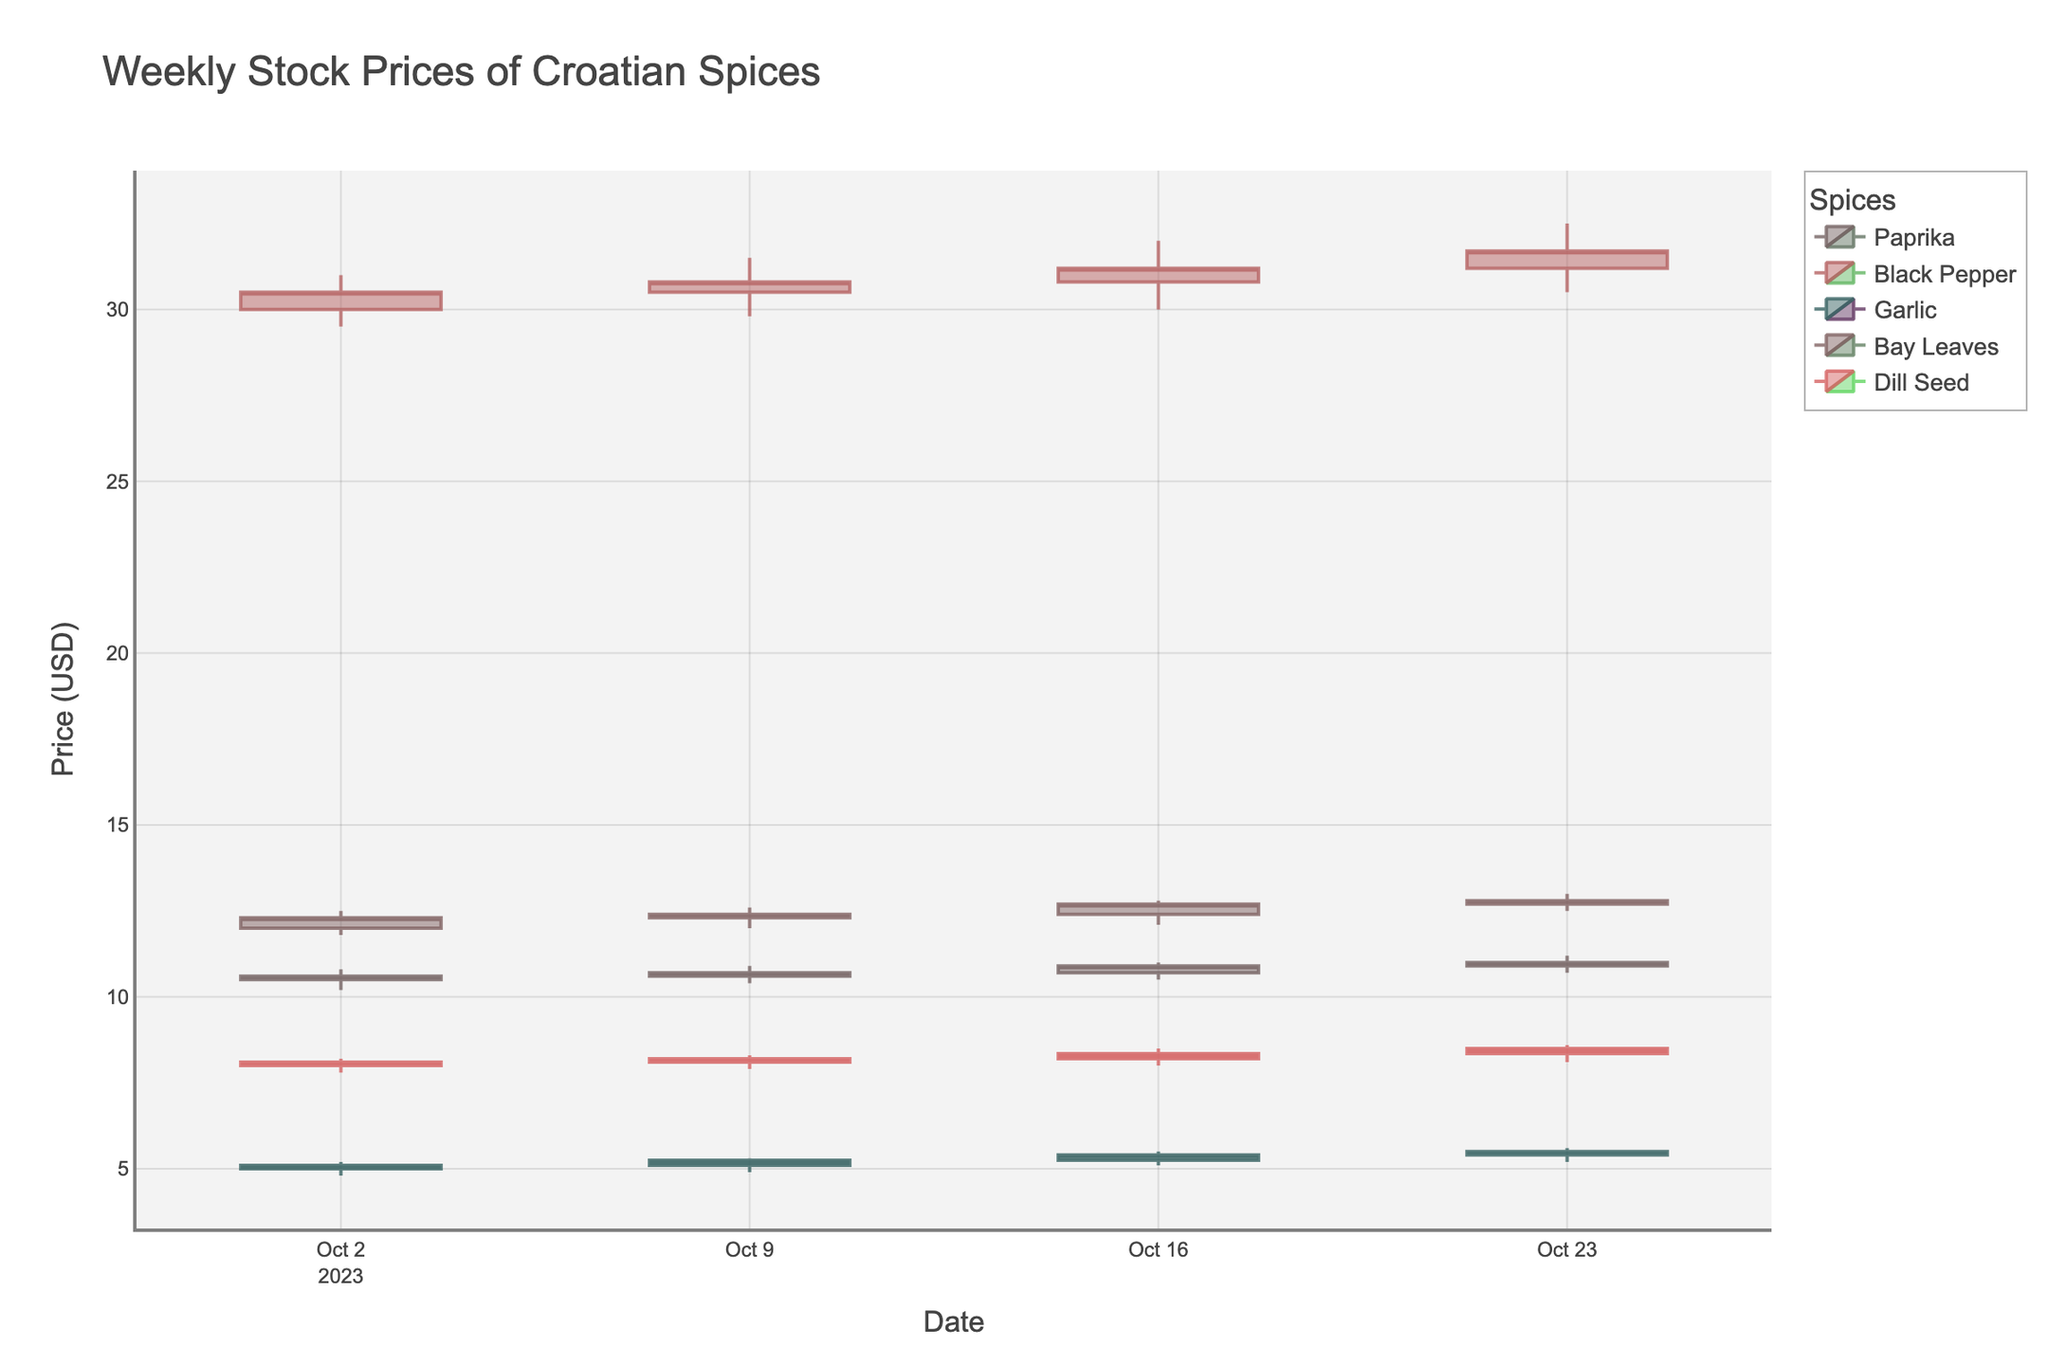What is the title of the figure? The title of the figure is typically displayed at the top. In this case, it reads "Weekly Stock Prices of Croatian Spices".
Answer: "Weekly Stock Prices of Croatian Spices" Which spice had the highest closing price on October 23, 2023? From the candlestick representing the stock data on October 23, 2023, we can observe that Black Pepper had the highest closing price.
Answer: Black Pepper On which date did Black Pepper see the highest volume of trading? By checking the volume bars associated with Black Pepper over the given dates, October 23, 2023 shows the highest trading volume.
Answer: October 23, 2023 What is the range of the closing prices of Garlic over the entire period? Reviewing the series of candlestick plots for Garlic, the lowest closing price is $5.10 on October 2, 2023, and the highest closing price is $5.50 on October 23, 2023.
Answer: $5.10 to $5.50 Which spice demonstrated the most consistent closing price changes over the period? By observing the closing prices of each spice over time, Dill Seed shows the least variation, gradually increasing from $8.10 to $8.50.
Answer: Dill Seed How did the closing price of Bay Leaves change from October 2, 2023, to October 23, 2023? The closing price of Bay Leaves increased from $12.30 on October 2, 2023, to $12.80 on October 23, 2023. So, it ascended consistently over the weeks.
Answer: Increased What was the highest peak (high price) observed for Paprika and when did it occur? The highest peak for Paprika can be seen reaching $11.20 on October 23, 2023, as indicated by the top wick of the candlestick on that date.
Answer: $11.20 on October 23, 2023 Compare the opening and closing prices of Dill Seed from October 16, 2023. Did the price increase or decrease? The figure shows that Dill Seed opened at $8.20 and closed at $8.35 on October 16, 2023, indicating an increase.
Answer: Increased Between October 9, 2023, and October 16, 2023, which spice had the largest increase in closing price? By comparing the closing prices on October 9 and October 16, Black Pepper increased from $30.80 to $31.20, marking it the largest increase among the spices.
Answer: Black Pepper What trend can be observed for Garlic's prices over the entire period? Reviewing Garlic’s candlesticks over the weeks, it shows a consistent upward trend in closing prices from $5.10 to $5.50.
Answer: Upward trend 